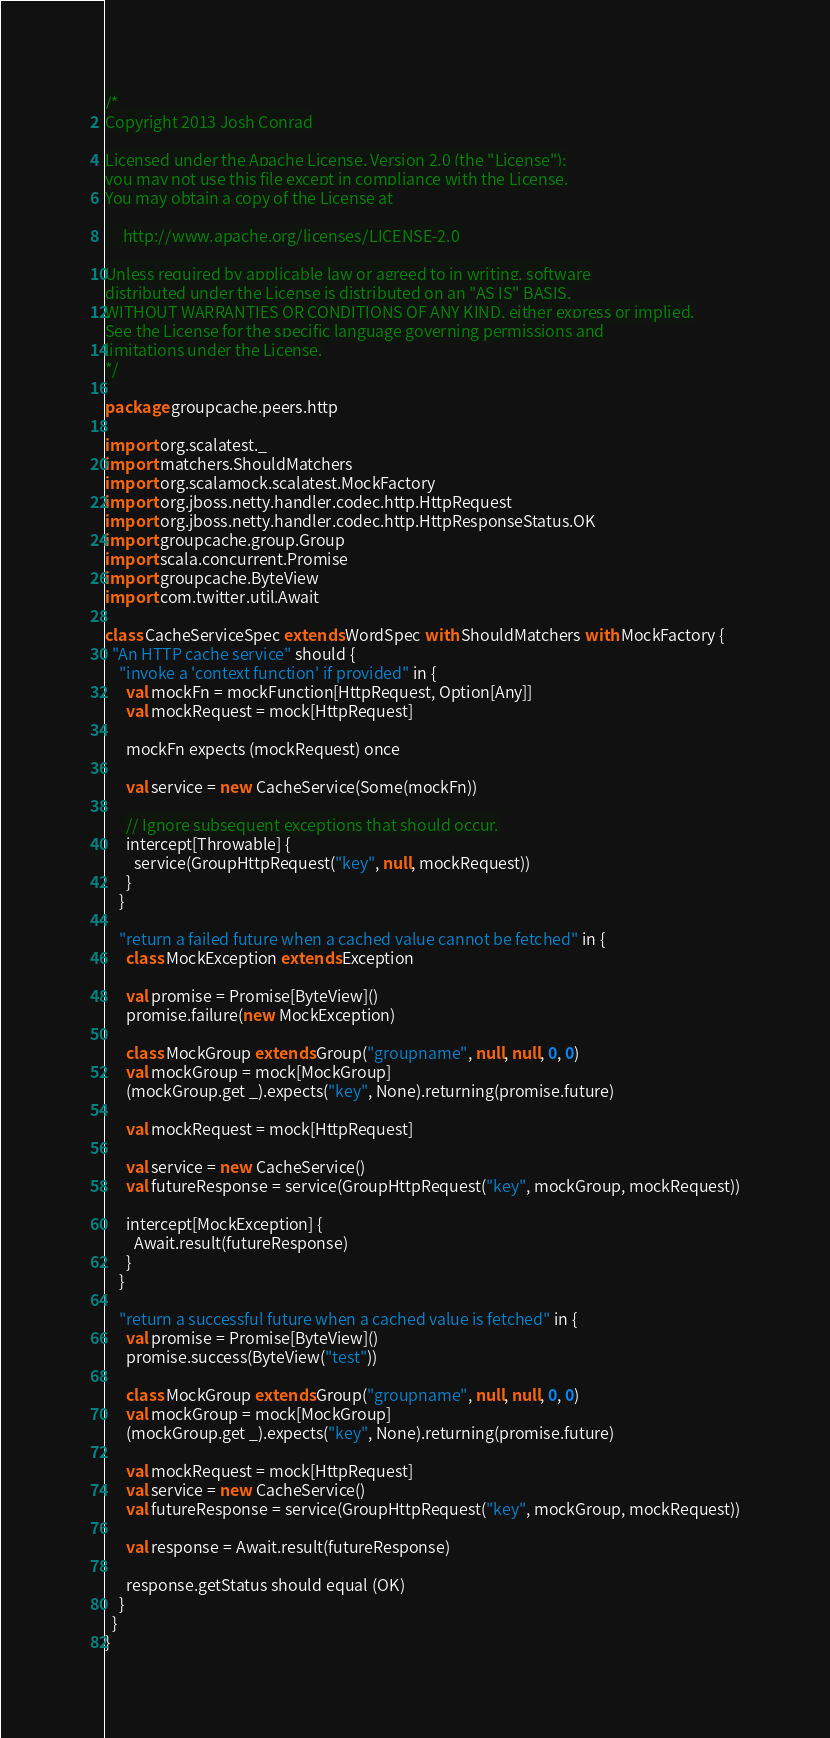Convert code to text. <code><loc_0><loc_0><loc_500><loc_500><_Scala_>/*
Copyright 2013 Josh Conrad

Licensed under the Apache License, Version 2.0 (the "License");
you may not use this file except in compliance with the License.
You may obtain a copy of the License at

     http://www.apache.org/licenses/LICENSE-2.0

Unless required by applicable law or agreed to in writing, software
distributed under the License is distributed on an "AS IS" BASIS,
WITHOUT WARRANTIES OR CONDITIONS OF ANY KIND, either express or implied.
See the License for the specific language governing permissions and
limitations under the License.
*/

package groupcache.peers.http

import org.scalatest._
import matchers.ShouldMatchers
import org.scalamock.scalatest.MockFactory
import org.jboss.netty.handler.codec.http.HttpRequest
import org.jboss.netty.handler.codec.http.HttpResponseStatus.OK
import groupcache.group.Group
import scala.concurrent.Promise
import groupcache.ByteView
import com.twitter.util.Await

class CacheServiceSpec extends WordSpec with ShouldMatchers with MockFactory {
  "An HTTP cache service" should {
    "invoke a 'context function' if provided" in {
      val mockFn = mockFunction[HttpRequest, Option[Any]]
      val mockRequest = mock[HttpRequest]

      mockFn expects (mockRequest) once

      val service = new CacheService(Some(mockFn))

      // Ignore subsequent exceptions that should occur.
      intercept[Throwable] {
        service(GroupHttpRequest("key", null, mockRequest))
      }
    }

    "return a failed future when a cached value cannot be fetched" in {
      class MockException extends Exception

      val promise = Promise[ByteView]()
      promise.failure(new MockException)

      class MockGroup extends Group("groupname", null, null, 0, 0)
      val mockGroup = mock[MockGroup]
      (mockGroup.get _).expects("key", None).returning(promise.future)

      val mockRequest = mock[HttpRequest]

      val service = new CacheService()
      val futureResponse = service(GroupHttpRequest("key", mockGroup, mockRequest))

      intercept[MockException] {
        Await.result(futureResponse)
      }
    }

    "return a successful future when a cached value is fetched" in {
      val promise = Promise[ByteView]()
      promise.success(ByteView("test"))

      class MockGroup extends Group("groupname", null, null, 0, 0)
      val mockGroup = mock[MockGroup]
      (mockGroup.get _).expects("key", None).returning(promise.future)

      val mockRequest = mock[HttpRequest]
      val service = new CacheService()
      val futureResponse = service(GroupHttpRequest("key", mockGroup, mockRequest))

      val response = Await.result(futureResponse)

      response.getStatus should equal (OK)
    }
  }
}

</code> 